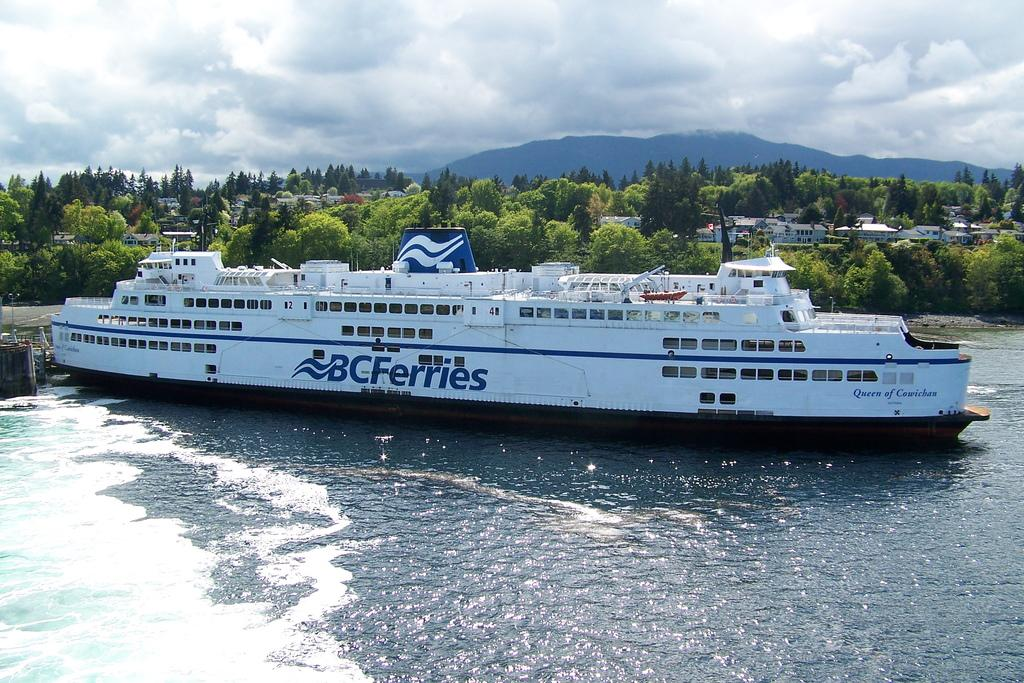What is the main subject of the image? The main subject of the image is a ship in the water. What can be seen in the background of the image? In the background of the image, there are trees, houses, mountains, and the sky. What is the weather like in the image? The image was taken during a sunny day, so the weather is clear and sunny. How many friends are on the ship in the image? There is no information about friends on the ship in the image, as it only shows the ship in the water. What type of care can be seen being provided to the trees in the image? There is no care being provided to the trees in the image, as it only shows the trees in the background. 